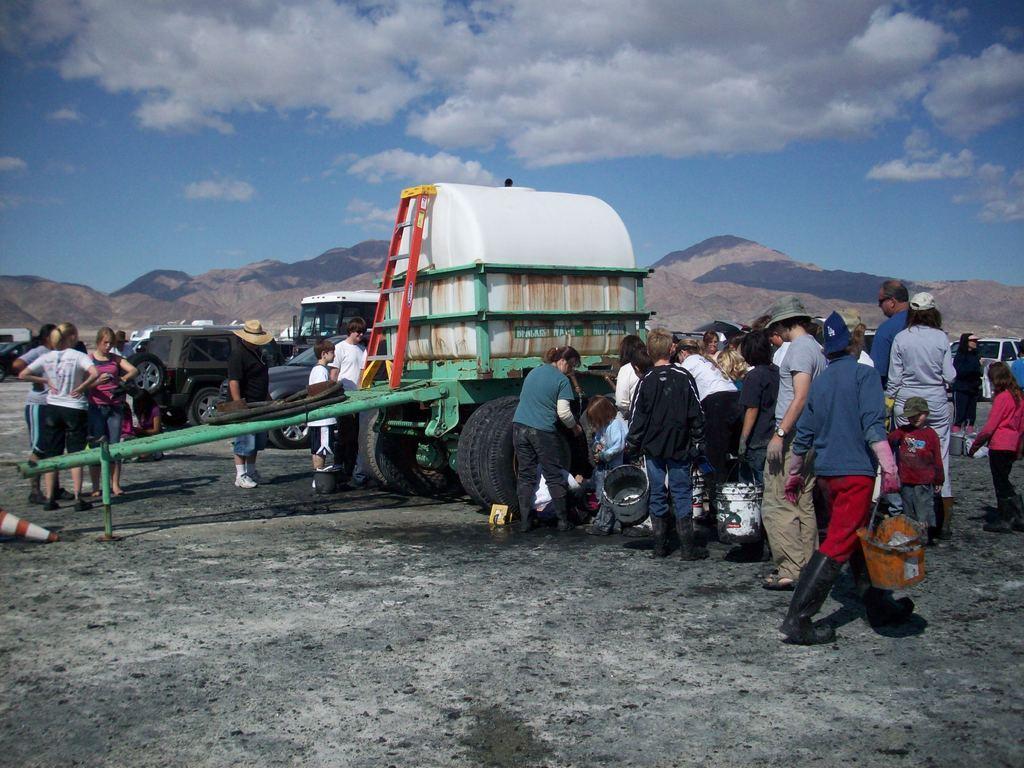Could you give a brief overview of what you see in this image? In this image I can see a cart and some other vehicles in the center of the image and few people standing and walking, among which few people are holding some objects in their hands in the center of the image and I can see mountains. At the bottom of the image I can see black soil. At the top of the image I can see the sky.  